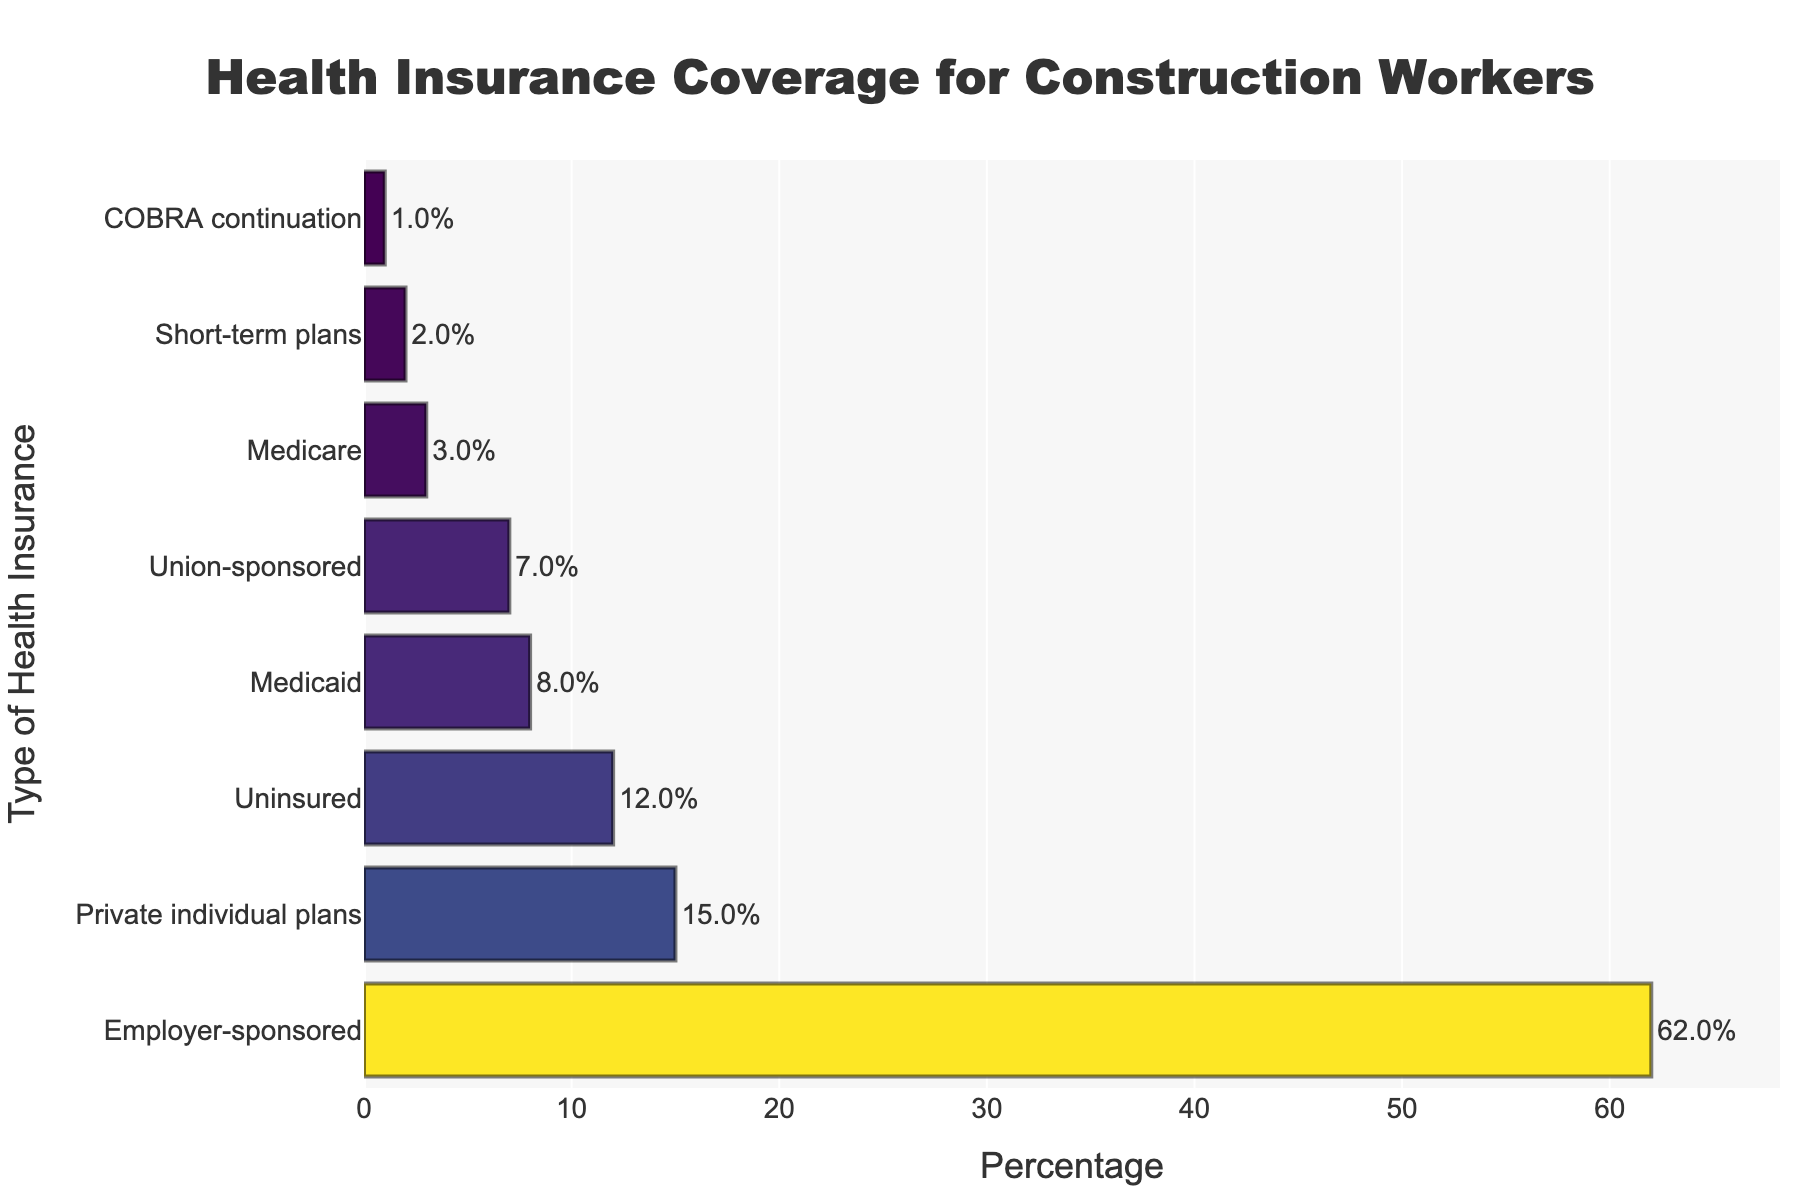What type of health insurance has the highest percentage among construction workers? The bar chart shows the different types of health insurance and their corresponding percentages for construction workers. The bar labeled "Employer-sponsored" is the longest, indicating the highest percentage.
Answer: Employer-sponsored Which two types of health insurance have a combined percentage higher than 70%? Observing the bar chart, "Employer-sponsored" has 62% and "Private individual plans" has 15%. Summing these two percentages: 62% + 15% = 77%, which is higher than 70%.
Answer: Employer-sponsored and Private individual plans How much higher is the percentage of uninsured workers compared to those with Medicaid coverage? The percentage of uninsured workers is 12%, and those with Medicaid coverage is 8%. Subtracting these two percentages: 12% - 8% = 4%.
Answer: 4% Which type of health insurance coverage is closest in percentage to Union-sponsored coverage? Observing the bar chart, Union-sponsored coverage is at 7%, and the type closest to this percentage is Medicaid at 8%.
Answer: Medicaid What is the difference between the percentages of the highest and the lowest types of health insurance? The highest percentage is "Employer-sponsored" at 62%, and the lowest is "COBRA continuation" at 1%. The difference is: 62% - 1% = 61%.
Answer: 61% How many types of health insurance have percentages below 10%? The bars showing percentages less than 10% are "Medicaid" (8%), "Medicare" (3%), "Union-sponsored" (7%), "Short-term plans" (2%), and "COBRA continuation" (1%). Counting them: 1, 2, 3, 4, 5.
Answer: 5 Which type of health insurance has a percentage that is about twice that of Uninsured? The Uninsured category is at 12%. Twice that is approximately 24%. No category matches 24%, but "Private individual plans" at 15% is the closest higher percentage to twice that of Uninsured.
Answer: Private individual plans 